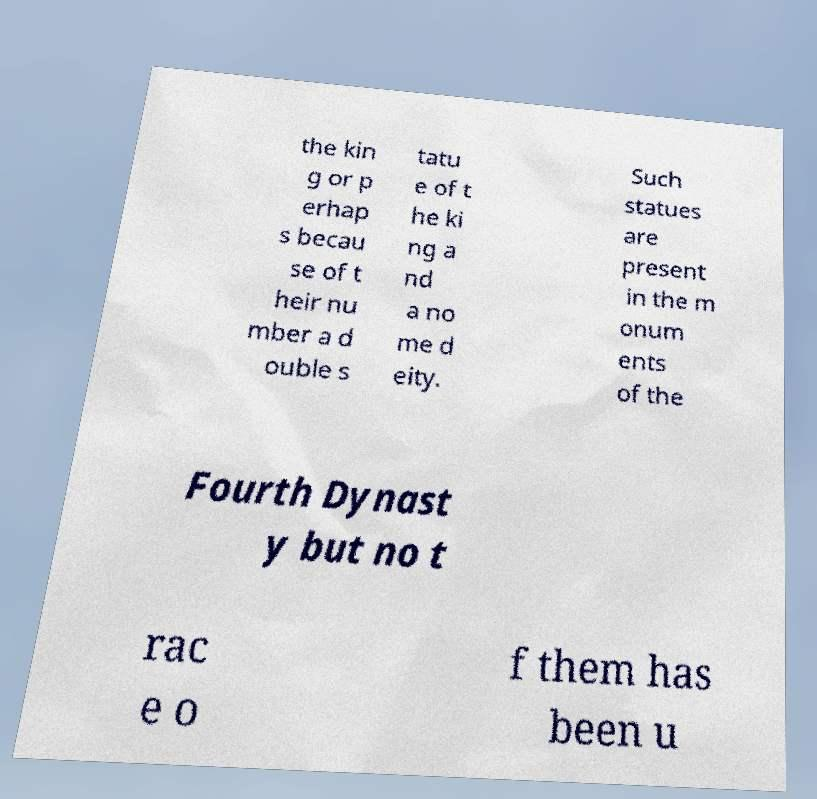Please read and relay the text visible in this image. What does it say? the kin g or p erhap s becau se of t heir nu mber a d ouble s tatu e of t he ki ng a nd a no me d eity. Such statues are present in the m onum ents of the Fourth Dynast y but no t rac e o f them has been u 